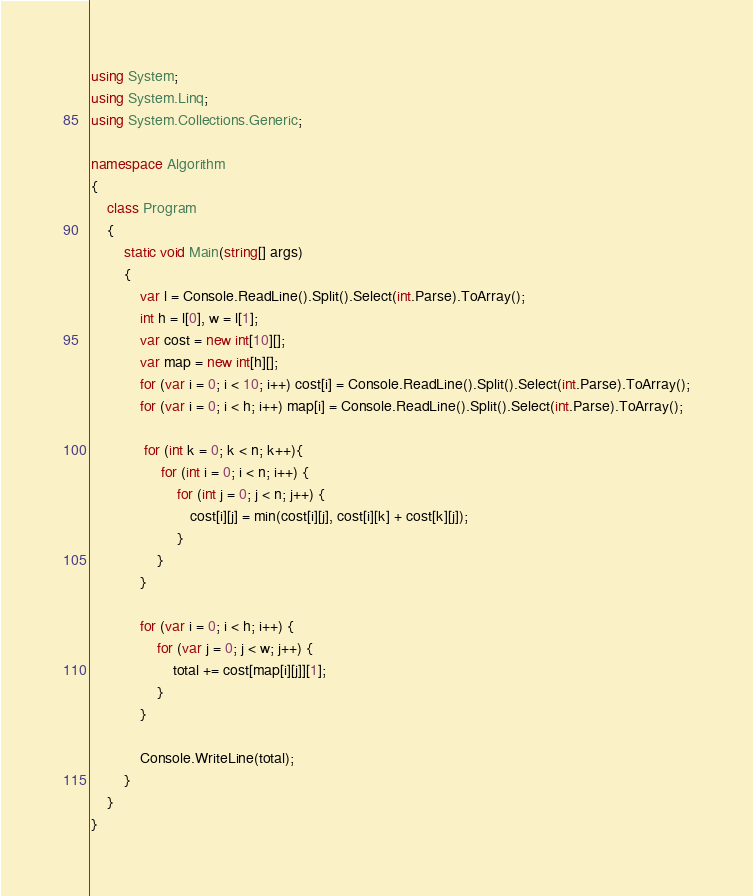<code> <loc_0><loc_0><loc_500><loc_500><_C#_>using System;
using System.Linq;
using System.Collections.Generic;

namespace Algorithm
{
    class Program
    {
        static void Main(string[] args)
        {
            var l = Console.ReadLine().Split().Select(int.Parse).ToArray();
            int h = l[0], w = l[1];
            var cost = new int[10][];
            var map = new int[h][];
            for (var i = 0; i < 10; i++) cost[i] = Console.ReadLine().Split().Select(int.Parse).ToArray();
            for (var i = 0; i < h; i++) map[i] = Console.ReadLine().Split().Select(int.Parse).ToArray();

             for (int k = 0; k < n; k++){
                 for (int i = 0; i < n; i++) {
                     for (int j = 0; j < n; j++) { 
                        cost[i][j] = min(cost[i][j], cost[i][k] + cost[k][j]);
                     }
                }
            }

            for (var i = 0; i < h; i++) {
                for (var j = 0; j < w; j++) {
                    total += cost[map[i][j]][1];
                }
            }

            Console.WriteLine(total);
        }
    }
}
</code> 